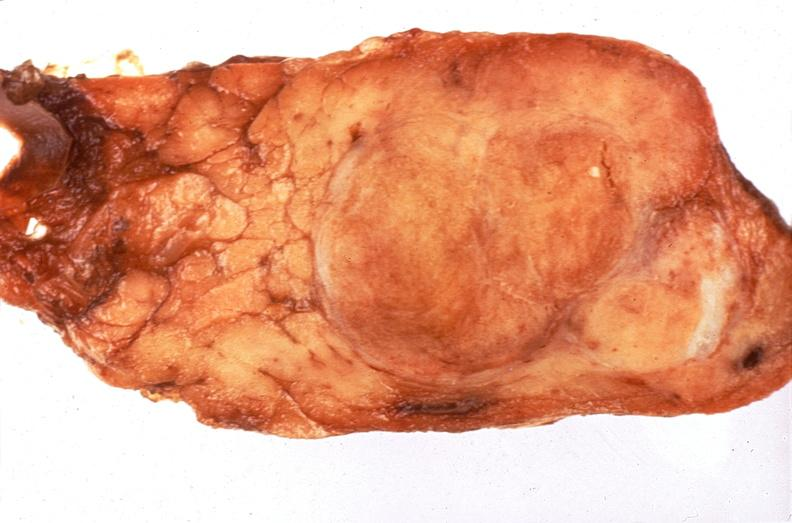where does this belong to?
Answer the question using a single word or phrase. Endocrine system 